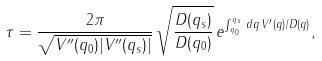Convert formula to latex. <formula><loc_0><loc_0><loc_500><loc_500>\tau = \frac { 2 \pi } { \sqrt { V ^ { \prime \prime } ( q _ { 0 } ) | V ^ { \prime \prime } ( q _ { s } ) | } } \, \sqrt { \frac { D ( q _ { s } ) } { D ( q _ { 0 } ) } } \, e ^ { \int _ { q _ { 0 } } ^ { q _ { s } } \, d q \, V ^ { \prime } ( q ) / D ( q ) } ,</formula> 